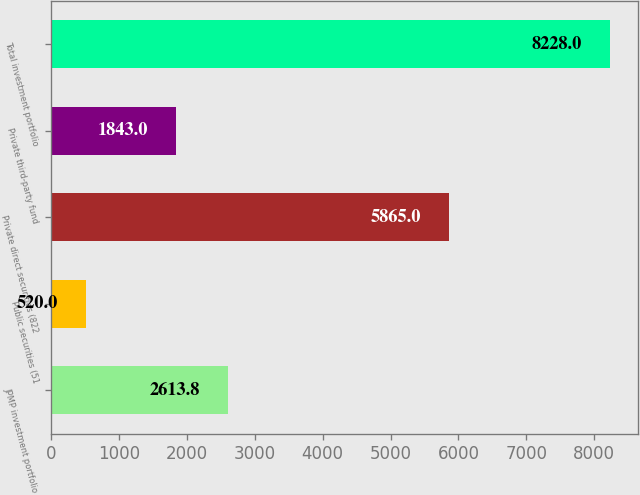Convert chart to OTSL. <chart><loc_0><loc_0><loc_500><loc_500><bar_chart><fcel>JPMP investment portfolio<fcel>Public securities (51<fcel>Private direct securities (822<fcel>Private third-party fund<fcel>Total investment portfolio<nl><fcel>2613.8<fcel>520<fcel>5865<fcel>1843<fcel>8228<nl></chart> 